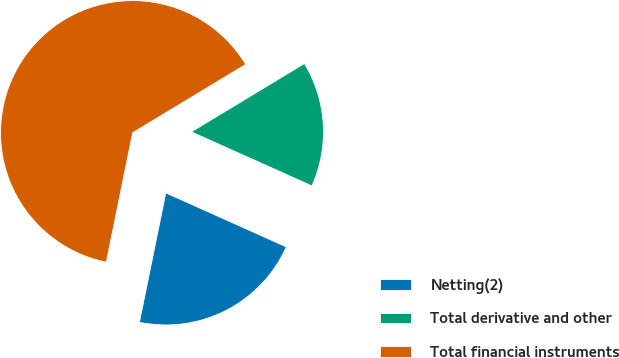Convert chart to OTSL. <chart><loc_0><loc_0><loc_500><loc_500><pie_chart><fcel>Netting(2)<fcel>Total derivative and other<fcel>Total financial instruments<nl><fcel>21.49%<fcel>15.36%<fcel>63.15%<nl></chart> 